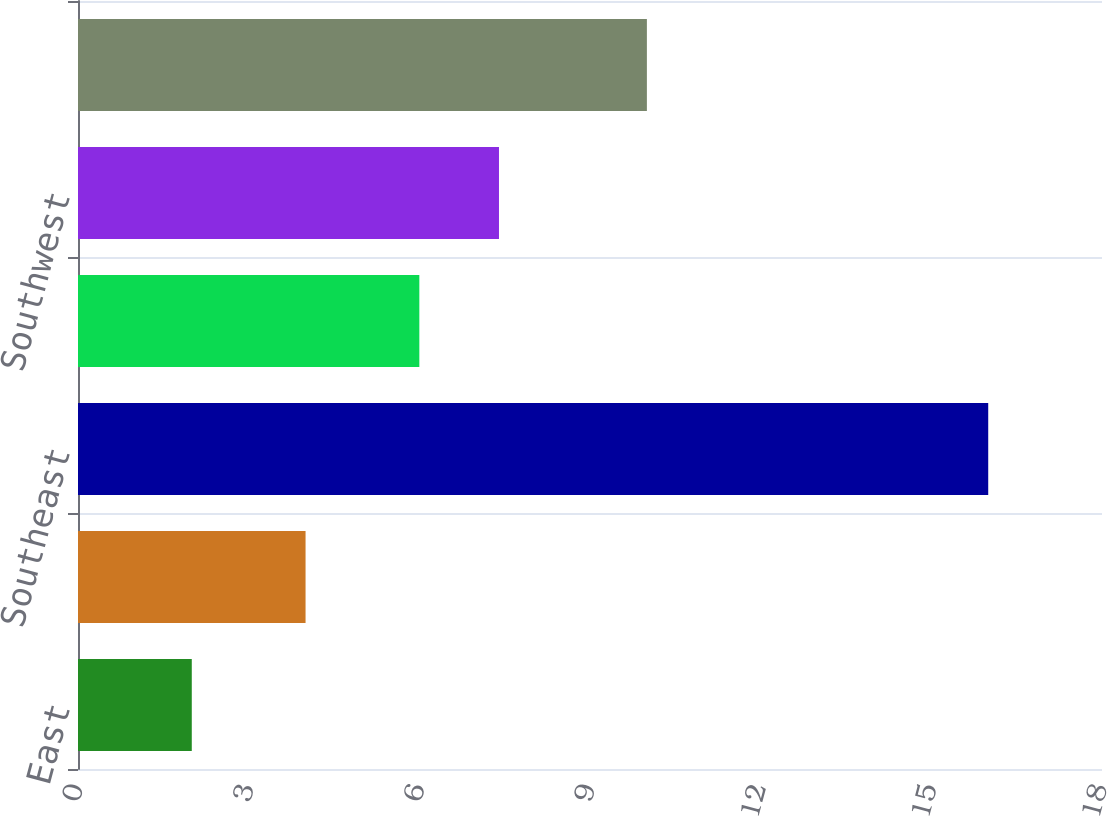<chart> <loc_0><loc_0><loc_500><loc_500><bar_chart><fcel>East<fcel>Midwest<fcel>Southeast<fcel>South Central<fcel>Southwest<fcel>West<nl><fcel>2<fcel>4<fcel>16<fcel>6<fcel>7.4<fcel>10<nl></chart> 